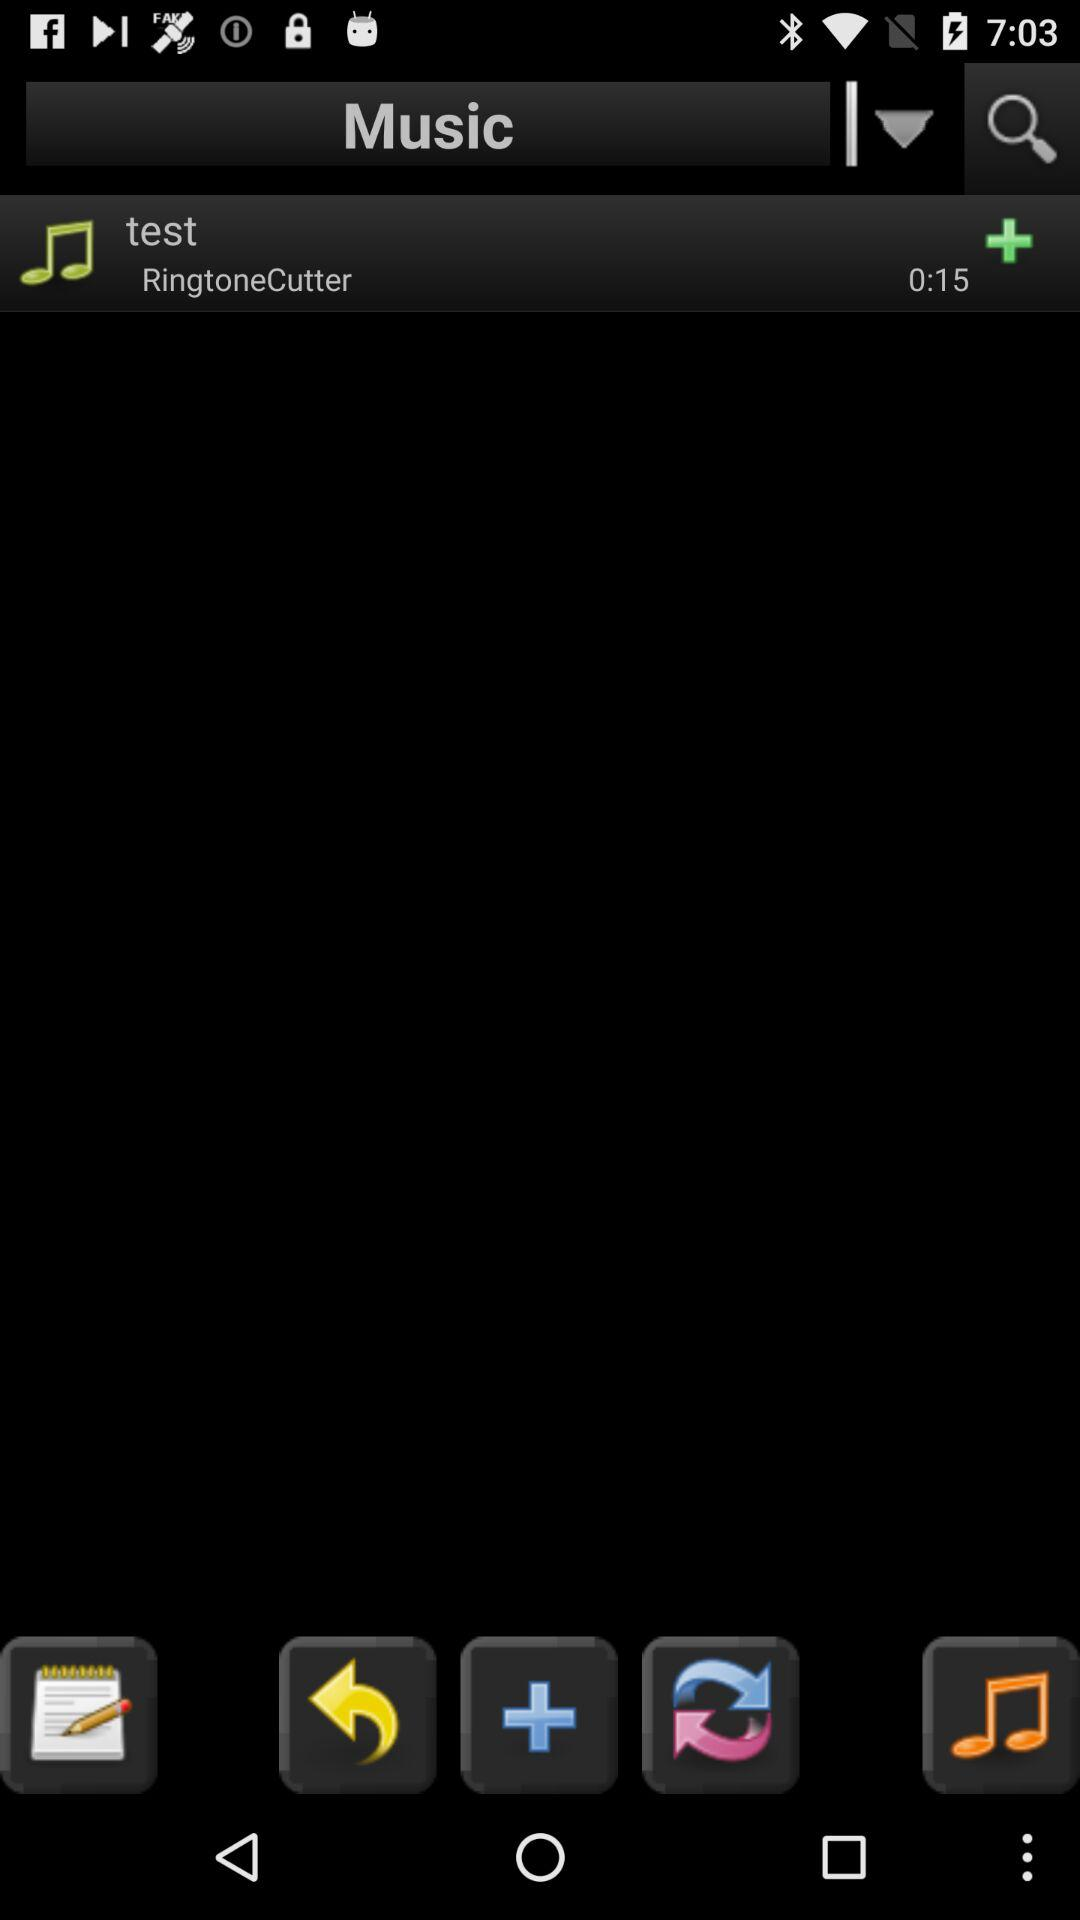What is the duration of the "test"? The duration of the "test" is 15 seconds. 